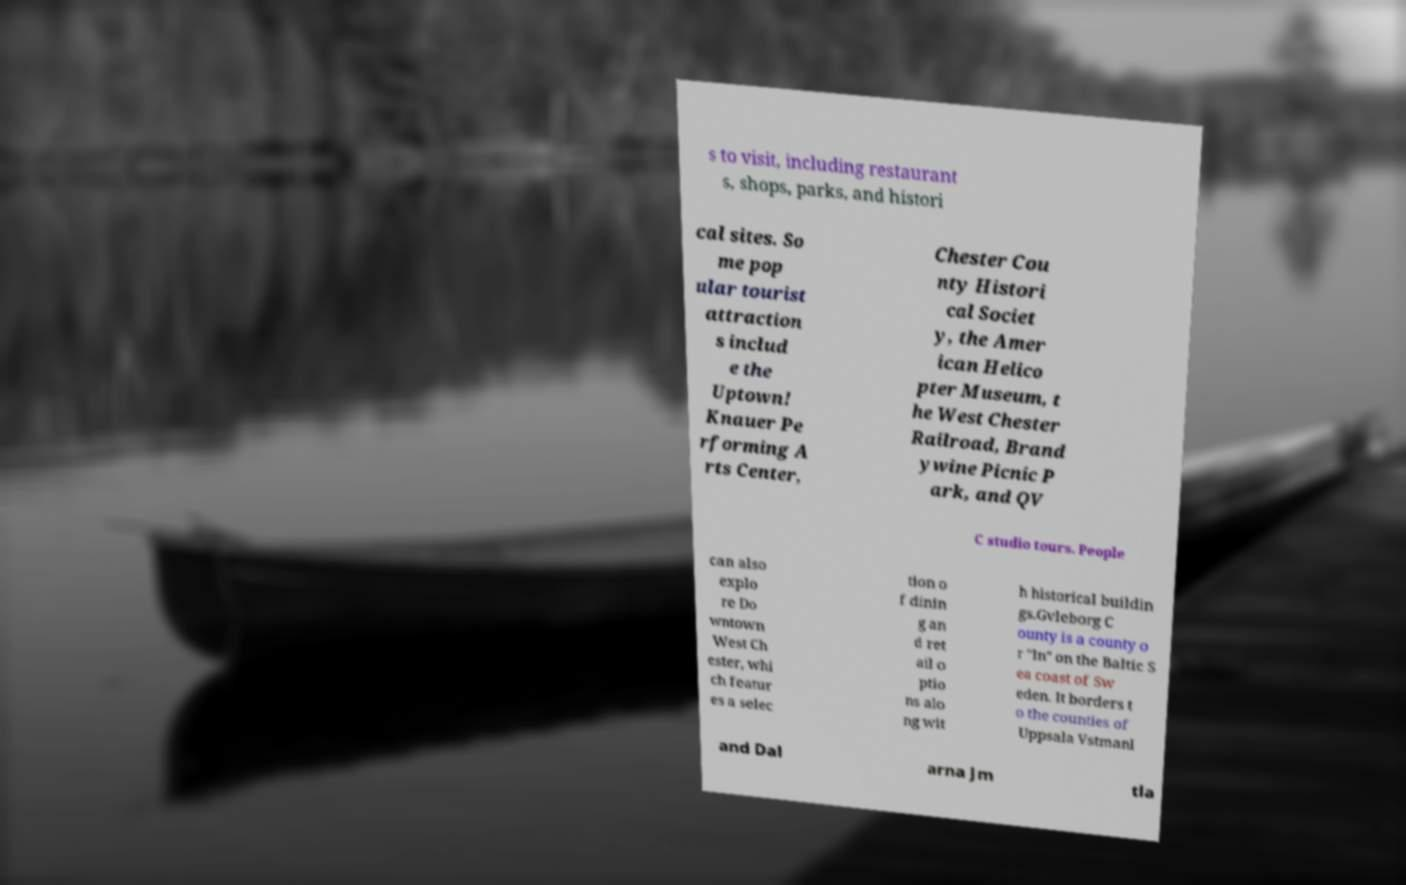For documentation purposes, I need the text within this image transcribed. Could you provide that? s to visit, including restaurant s, shops, parks, and histori cal sites. So me pop ular tourist attraction s includ e the Uptown! Knauer Pe rforming A rts Center, Chester Cou nty Histori cal Societ y, the Amer ican Helico pter Museum, t he West Chester Railroad, Brand ywine Picnic P ark, and QV C studio tours. People can also explo re Do wntown West Ch ester, whi ch featur es a selec tion o f dinin g an d ret ail o ptio ns alo ng wit h historical buildin gs.Gvleborg C ounty is a county o r "ln" on the Baltic S ea coast of Sw eden. It borders t o the counties of Uppsala Vstmanl and Dal arna Jm tla 